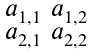Convert formula to latex. <formula><loc_0><loc_0><loc_500><loc_500>\begin{smallmatrix} a _ { 1 , 1 } & a _ { 1 , 2 } \\ a _ { 2 , 1 } & a _ { 2 , 2 } \end{smallmatrix}</formula> 